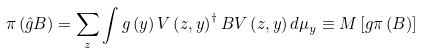Convert formula to latex. <formula><loc_0><loc_0><loc_500><loc_500>\pi \left ( \hat { g } B \right ) = \sum _ { z } \int g \left ( y \right ) V \left ( z , y \right ) ^ { \dagger } B V \left ( z , y \right ) d \mu _ { y } \equiv M \left [ g \pi \left ( B \right ) \right ]</formula> 